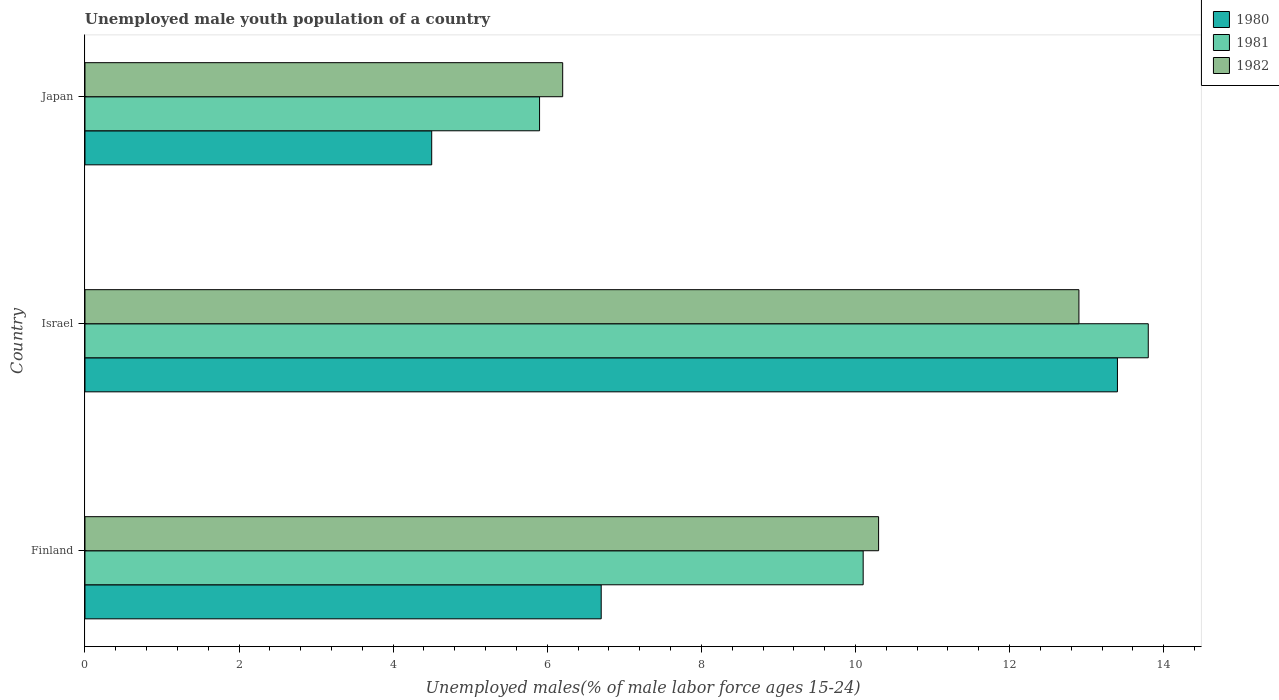How many different coloured bars are there?
Offer a terse response. 3. How many groups of bars are there?
Your answer should be very brief. 3. How many bars are there on the 1st tick from the top?
Your answer should be compact. 3. What is the label of the 3rd group of bars from the top?
Provide a succinct answer. Finland. In how many cases, is the number of bars for a given country not equal to the number of legend labels?
Keep it short and to the point. 0. What is the percentage of unemployed male youth population in 1981 in Japan?
Your response must be concise. 5.9. Across all countries, what is the maximum percentage of unemployed male youth population in 1982?
Your response must be concise. 12.9. In which country was the percentage of unemployed male youth population in 1982 maximum?
Your answer should be very brief. Israel. In which country was the percentage of unemployed male youth population in 1981 minimum?
Ensure brevity in your answer.  Japan. What is the total percentage of unemployed male youth population in 1981 in the graph?
Provide a succinct answer. 29.8. What is the difference between the percentage of unemployed male youth population in 1981 in Israel and that in Japan?
Your response must be concise. 7.9. What is the difference between the percentage of unemployed male youth population in 1981 in Israel and the percentage of unemployed male youth population in 1982 in Japan?
Make the answer very short. 7.6. What is the average percentage of unemployed male youth population in 1980 per country?
Provide a short and direct response. 8.2. What is the difference between the percentage of unemployed male youth population in 1980 and percentage of unemployed male youth population in 1982 in Japan?
Make the answer very short. -1.7. What is the ratio of the percentage of unemployed male youth population in 1982 in Finland to that in Japan?
Make the answer very short. 1.66. Is the percentage of unemployed male youth population in 1982 in Finland less than that in Israel?
Keep it short and to the point. Yes. Is the difference between the percentage of unemployed male youth population in 1980 in Finland and Japan greater than the difference between the percentage of unemployed male youth population in 1982 in Finland and Japan?
Make the answer very short. No. What is the difference between the highest and the second highest percentage of unemployed male youth population in 1981?
Make the answer very short. 3.7. What is the difference between the highest and the lowest percentage of unemployed male youth population in 1981?
Your response must be concise. 7.9. In how many countries, is the percentage of unemployed male youth population in 1980 greater than the average percentage of unemployed male youth population in 1980 taken over all countries?
Provide a succinct answer. 1. What does the 2nd bar from the top in Japan represents?
Ensure brevity in your answer.  1981. What does the 3rd bar from the bottom in Israel represents?
Keep it short and to the point. 1982. Is it the case that in every country, the sum of the percentage of unemployed male youth population in 1981 and percentage of unemployed male youth population in 1980 is greater than the percentage of unemployed male youth population in 1982?
Offer a terse response. Yes. How many bars are there?
Your response must be concise. 9. Does the graph contain any zero values?
Keep it short and to the point. No. Does the graph contain grids?
Your answer should be very brief. No. Where does the legend appear in the graph?
Provide a succinct answer. Top right. How are the legend labels stacked?
Your answer should be compact. Vertical. What is the title of the graph?
Provide a short and direct response. Unemployed male youth population of a country. Does "2010" appear as one of the legend labels in the graph?
Ensure brevity in your answer.  No. What is the label or title of the X-axis?
Provide a succinct answer. Unemployed males(% of male labor force ages 15-24). What is the label or title of the Y-axis?
Give a very brief answer. Country. What is the Unemployed males(% of male labor force ages 15-24) of 1980 in Finland?
Your answer should be compact. 6.7. What is the Unemployed males(% of male labor force ages 15-24) in 1981 in Finland?
Your answer should be very brief. 10.1. What is the Unemployed males(% of male labor force ages 15-24) in 1982 in Finland?
Make the answer very short. 10.3. What is the Unemployed males(% of male labor force ages 15-24) in 1980 in Israel?
Offer a very short reply. 13.4. What is the Unemployed males(% of male labor force ages 15-24) of 1981 in Israel?
Keep it short and to the point. 13.8. What is the Unemployed males(% of male labor force ages 15-24) in 1982 in Israel?
Your answer should be compact. 12.9. What is the Unemployed males(% of male labor force ages 15-24) in 1980 in Japan?
Offer a terse response. 4.5. What is the Unemployed males(% of male labor force ages 15-24) in 1981 in Japan?
Offer a very short reply. 5.9. What is the Unemployed males(% of male labor force ages 15-24) in 1982 in Japan?
Provide a succinct answer. 6.2. Across all countries, what is the maximum Unemployed males(% of male labor force ages 15-24) in 1980?
Offer a terse response. 13.4. Across all countries, what is the maximum Unemployed males(% of male labor force ages 15-24) of 1981?
Offer a terse response. 13.8. Across all countries, what is the maximum Unemployed males(% of male labor force ages 15-24) of 1982?
Provide a short and direct response. 12.9. Across all countries, what is the minimum Unemployed males(% of male labor force ages 15-24) in 1981?
Offer a very short reply. 5.9. Across all countries, what is the minimum Unemployed males(% of male labor force ages 15-24) in 1982?
Give a very brief answer. 6.2. What is the total Unemployed males(% of male labor force ages 15-24) in 1980 in the graph?
Make the answer very short. 24.6. What is the total Unemployed males(% of male labor force ages 15-24) in 1981 in the graph?
Ensure brevity in your answer.  29.8. What is the total Unemployed males(% of male labor force ages 15-24) of 1982 in the graph?
Provide a short and direct response. 29.4. What is the difference between the Unemployed males(% of male labor force ages 15-24) of 1980 in Finland and that in Israel?
Provide a short and direct response. -6.7. What is the difference between the Unemployed males(% of male labor force ages 15-24) in 1981 in Finland and that in Israel?
Your answer should be compact. -3.7. What is the difference between the Unemployed males(% of male labor force ages 15-24) in 1982 in Finland and that in Israel?
Make the answer very short. -2.6. What is the difference between the Unemployed males(% of male labor force ages 15-24) in 1980 in Finland and that in Japan?
Your answer should be very brief. 2.2. What is the difference between the Unemployed males(% of male labor force ages 15-24) in 1982 in Finland and that in Japan?
Offer a very short reply. 4.1. What is the difference between the Unemployed males(% of male labor force ages 15-24) of 1980 in Finland and the Unemployed males(% of male labor force ages 15-24) of 1981 in Israel?
Give a very brief answer. -7.1. What is the difference between the Unemployed males(% of male labor force ages 15-24) in 1981 in Finland and the Unemployed males(% of male labor force ages 15-24) in 1982 in Israel?
Ensure brevity in your answer.  -2.8. What is the difference between the Unemployed males(% of male labor force ages 15-24) in 1980 in Israel and the Unemployed males(% of male labor force ages 15-24) in 1981 in Japan?
Provide a short and direct response. 7.5. What is the difference between the Unemployed males(% of male labor force ages 15-24) in 1980 in Israel and the Unemployed males(% of male labor force ages 15-24) in 1982 in Japan?
Your answer should be very brief. 7.2. What is the difference between the Unemployed males(% of male labor force ages 15-24) of 1981 in Israel and the Unemployed males(% of male labor force ages 15-24) of 1982 in Japan?
Give a very brief answer. 7.6. What is the average Unemployed males(% of male labor force ages 15-24) in 1980 per country?
Make the answer very short. 8.2. What is the average Unemployed males(% of male labor force ages 15-24) in 1981 per country?
Keep it short and to the point. 9.93. What is the difference between the Unemployed males(% of male labor force ages 15-24) of 1980 and Unemployed males(% of male labor force ages 15-24) of 1982 in Israel?
Your answer should be compact. 0.5. What is the difference between the Unemployed males(% of male labor force ages 15-24) in 1980 and Unemployed males(% of male labor force ages 15-24) in 1981 in Japan?
Offer a terse response. -1.4. What is the ratio of the Unemployed males(% of male labor force ages 15-24) in 1981 in Finland to that in Israel?
Make the answer very short. 0.73. What is the ratio of the Unemployed males(% of male labor force ages 15-24) of 1982 in Finland to that in Israel?
Ensure brevity in your answer.  0.8. What is the ratio of the Unemployed males(% of male labor force ages 15-24) of 1980 in Finland to that in Japan?
Your response must be concise. 1.49. What is the ratio of the Unemployed males(% of male labor force ages 15-24) of 1981 in Finland to that in Japan?
Ensure brevity in your answer.  1.71. What is the ratio of the Unemployed males(% of male labor force ages 15-24) in 1982 in Finland to that in Japan?
Your answer should be compact. 1.66. What is the ratio of the Unemployed males(% of male labor force ages 15-24) of 1980 in Israel to that in Japan?
Your answer should be compact. 2.98. What is the ratio of the Unemployed males(% of male labor force ages 15-24) in 1981 in Israel to that in Japan?
Keep it short and to the point. 2.34. What is the ratio of the Unemployed males(% of male labor force ages 15-24) in 1982 in Israel to that in Japan?
Give a very brief answer. 2.08. What is the difference between the highest and the second highest Unemployed males(% of male labor force ages 15-24) of 1980?
Your answer should be very brief. 6.7. What is the difference between the highest and the lowest Unemployed males(% of male labor force ages 15-24) of 1980?
Make the answer very short. 8.9. 